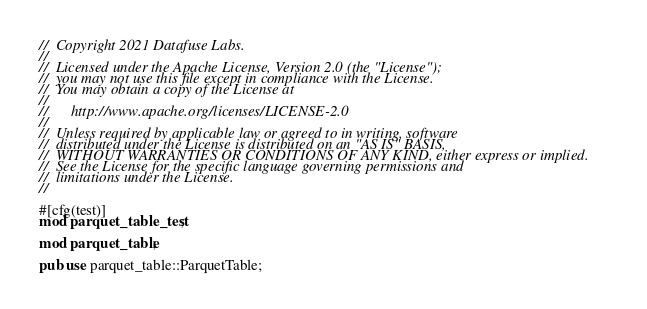<code> <loc_0><loc_0><loc_500><loc_500><_Rust_>//  Copyright 2021 Datafuse Labs.
//
//  Licensed under the Apache License, Version 2.0 (the "License");
//  you may not use this file except in compliance with the License.
//  You may obtain a copy of the License at
//
//      http://www.apache.org/licenses/LICENSE-2.0
//
//  Unless required by applicable law or agreed to in writing, software
//  distributed under the License is distributed on an "AS IS" BASIS,
//  WITHOUT WARRANTIES OR CONDITIONS OF ANY KIND, either express or implied.
//  See the License for the specific language governing permissions and
//  limitations under the License.
//

#[cfg(test)]
mod parquet_table_test;

mod parquet_table;

pub use parquet_table::ParquetTable;
</code> 